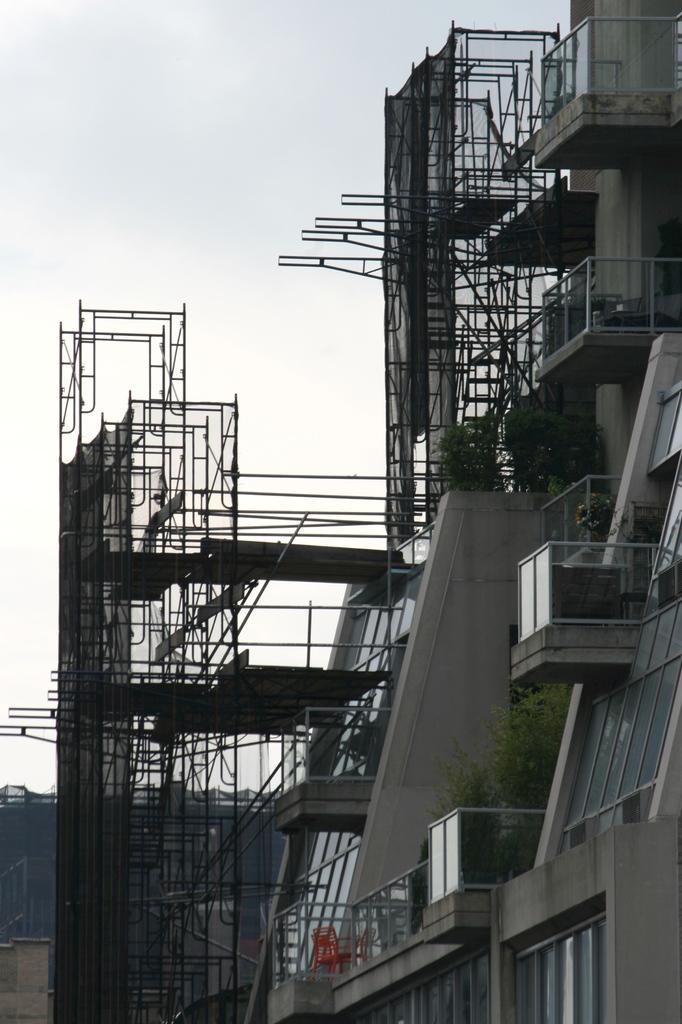Can you describe this image briefly? In this image there is a building on the right side of this image. There are some advertising boards are attached to this building. There is a sky on the top of this image. 